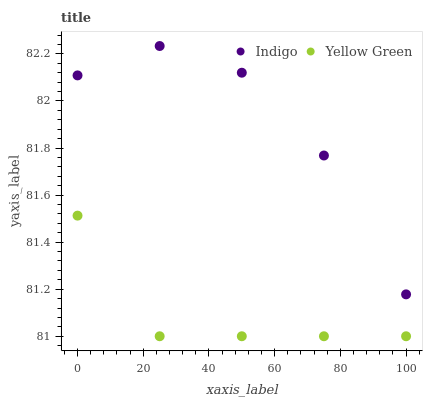Does Yellow Green have the minimum area under the curve?
Answer yes or no. Yes. Does Indigo have the maximum area under the curve?
Answer yes or no. Yes. Does Yellow Green have the maximum area under the curve?
Answer yes or no. No. Is Yellow Green the smoothest?
Answer yes or no. Yes. Is Indigo the roughest?
Answer yes or no. Yes. Is Yellow Green the roughest?
Answer yes or no. No. Does Yellow Green have the lowest value?
Answer yes or no. Yes. Does Indigo have the highest value?
Answer yes or no. Yes. Does Yellow Green have the highest value?
Answer yes or no. No. Is Yellow Green less than Indigo?
Answer yes or no. Yes. Is Indigo greater than Yellow Green?
Answer yes or no. Yes. Does Yellow Green intersect Indigo?
Answer yes or no. No. 